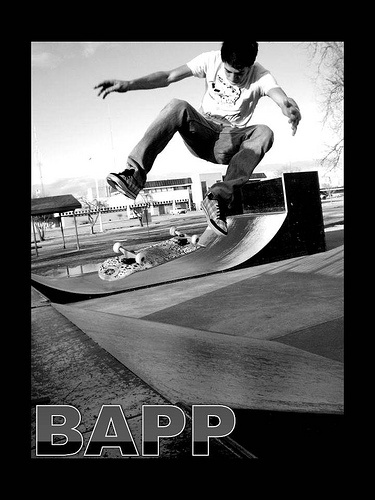Describe the objects in this image and their specific colors. I can see people in black, white, gray, and darkgray tones, skateboard in black, gray, darkgray, and gainsboro tones, and car in black, lightgray, darkgray, and gray tones in this image. 